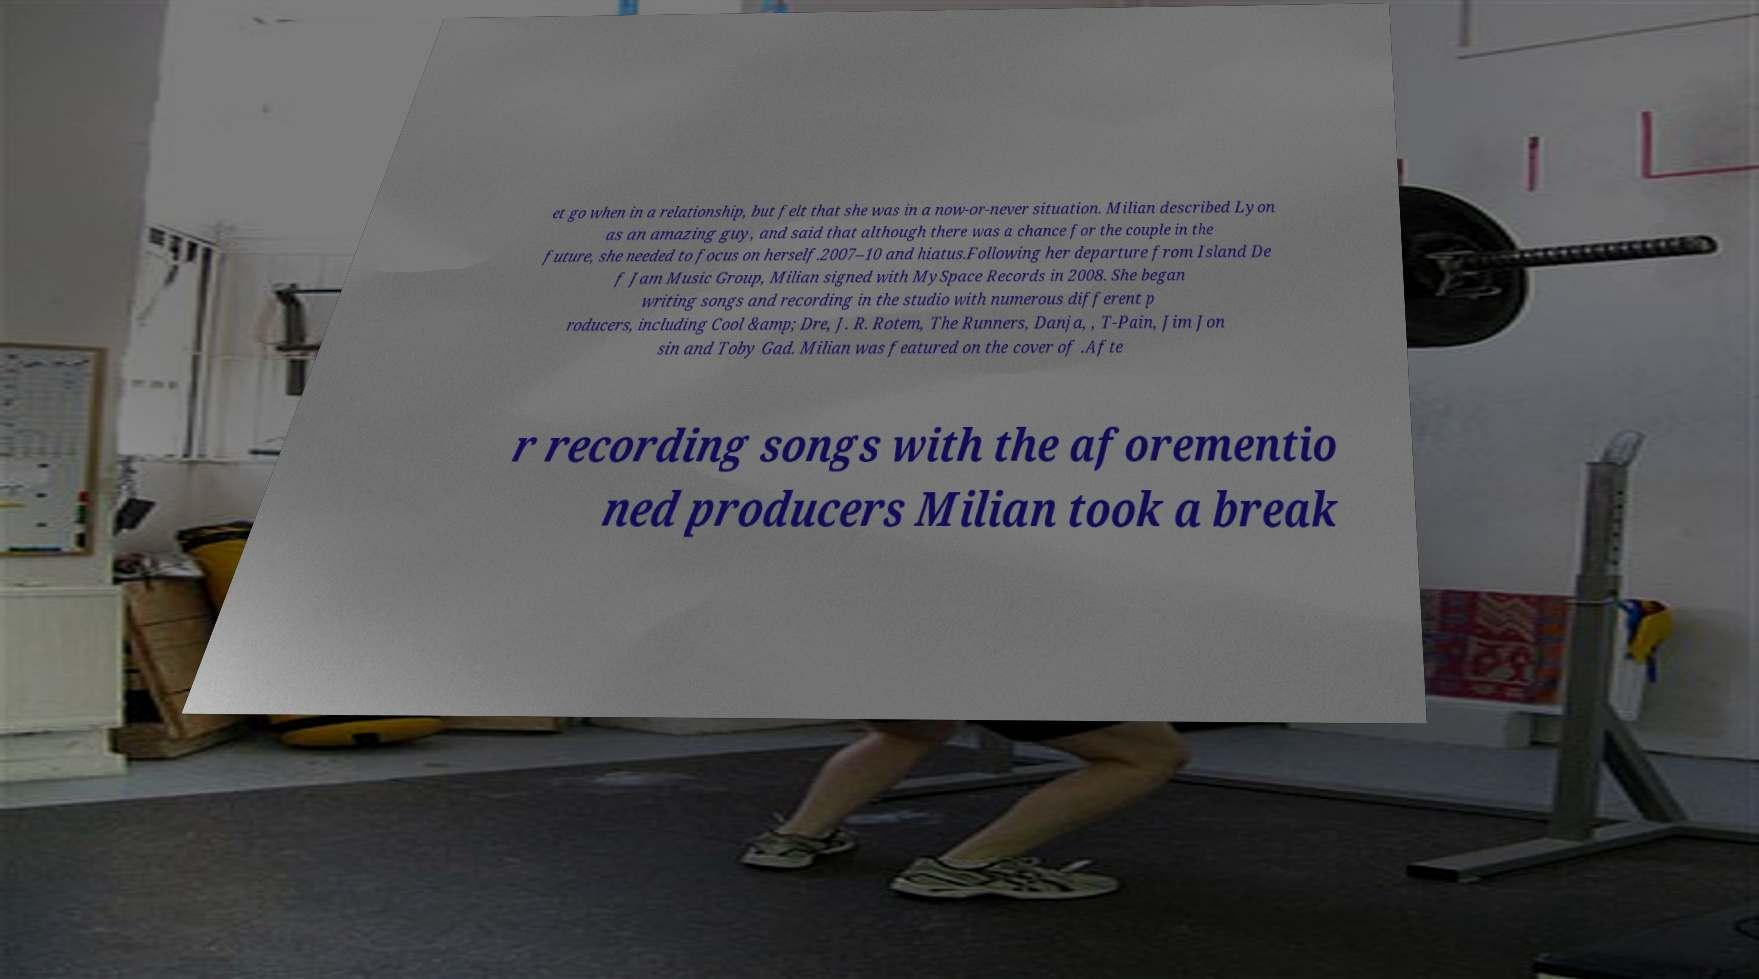Can you read and provide the text displayed in the image?This photo seems to have some interesting text. Can you extract and type it out for me? et go when in a relationship, but felt that she was in a now-or-never situation. Milian described Lyon as an amazing guy, and said that although there was a chance for the couple in the future, she needed to focus on herself.2007–10 and hiatus.Following her departure from Island De f Jam Music Group, Milian signed with MySpace Records in 2008. She began writing songs and recording in the studio with numerous different p roducers, including Cool &amp; Dre, J. R. Rotem, The Runners, Danja, , T-Pain, Jim Jon sin and Toby Gad. Milian was featured on the cover of .Afte r recording songs with the aforementio ned producers Milian took a break 